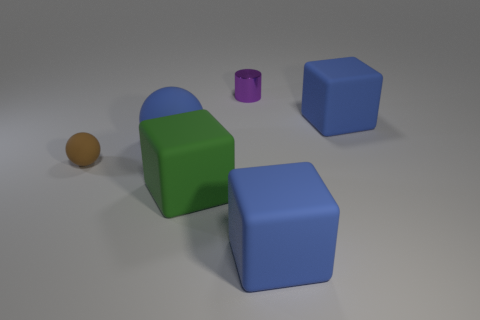Subtract all green blocks. How many blocks are left? 2 Subtract all blue rubber cubes. How many cubes are left? 1 Add 4 tiny rubber things. How many objects exist? 10 Subtract all cylinders. How many objects are left? 5 Subtract 1 cubes. How many cubes are left? 2 Add 3 big blue rubber objects. How many big blue rubber objects are left? 6 Add 4 purple metallic cylinders. How many purple metallic cylinders exist? 5 Subtract 0 cyan cylinders. How many objects are left? 6 Subtract all brown cylinders. Subtract all cyan blocks. How many cylinders are left? 1 Subtract all green spheres. How many green cylinders are left? 0 